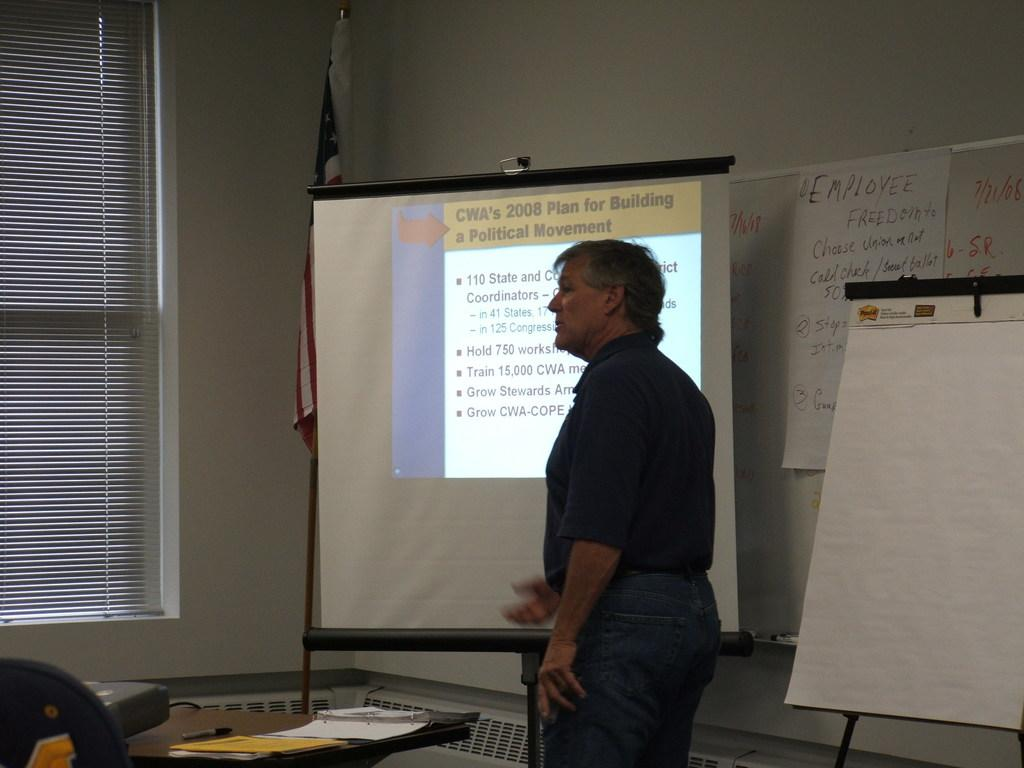<image>
Describe the image concisely. A man is giving a talk about CWA's 2008 plan for building a political movement. 